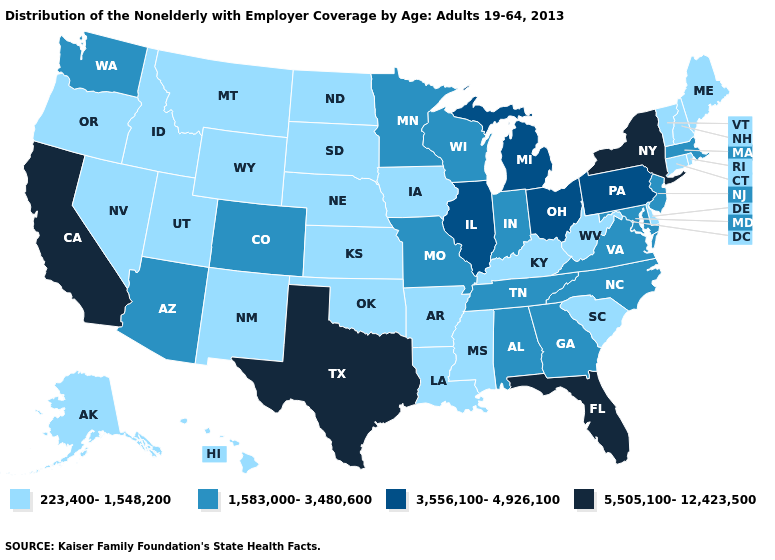Which states hav the highest value in the South?
Be succinct. Florida, Texas. Among the states that border New Jersey , which have the highest value?
Be succinct. New York. Which states hav the highest value in the Northeast?
Write a very short answer. New York. What is the value of Colorado?
Write a very short answer. 1,583,000-3,480,600. Which states have the lowest value in the West?
Short answer required. Alaska, Hawaii, Idaho, Montana, Nevada, New Mexico, Oregon, Utah, Wyoming. Is the legend a continuous bar?
Answer briefly. No. Does the map have missing data?
Keep it brief. No. How many symbols are there in the legend?
Give a very brief answer. 4. Does North Dakota have the lowest value in the MidWest?
Be succinct. Yes. Which states have the highest value in the USA?
Answer briefly. California, Florida, New York, Texas. Which states hav the highest value in the South?
Answer briefly. Florida, Texas. Which states hav the highest value in the West?
Answer briefly. California. What is the value of Nevada?
Short answer required. 223,400-1,548,200. What is the value of Vermont?
Answer briefly. 223,400-1,548,200. Does California have the highest value in the USA?
Short answer required. Yes. 